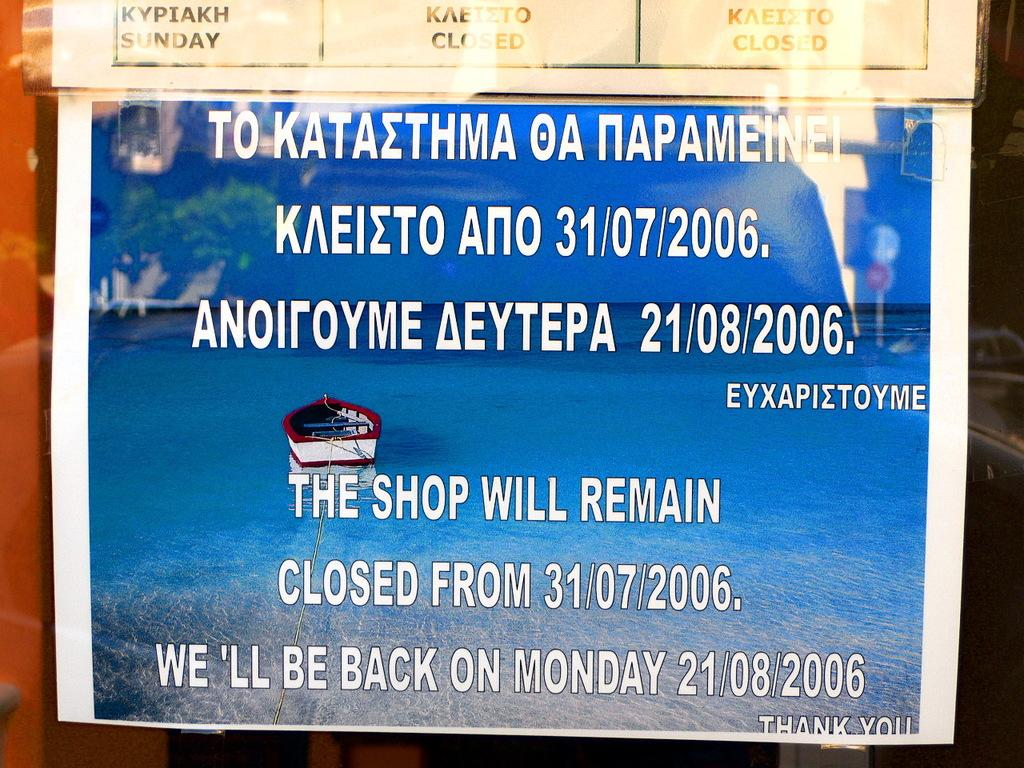What is the main object in the image? There is a pomp let in the image. What can be found on the pomp let? There is text and images on the pomp let. What images are present on the pomp let? There is an image of a boat and an image of the sea on the pomp let. Are there any other text elements on the pomp let? Yes, there is additional text on the pomp let. How does the pomp let help to keep the room quiet? The pomp let does not have any direct impact on the room's noise level; it is a decorative object with text and images. Does the pomp let have a tail? No, the pomp let does not have a tail; it is a flat, decorative object. 